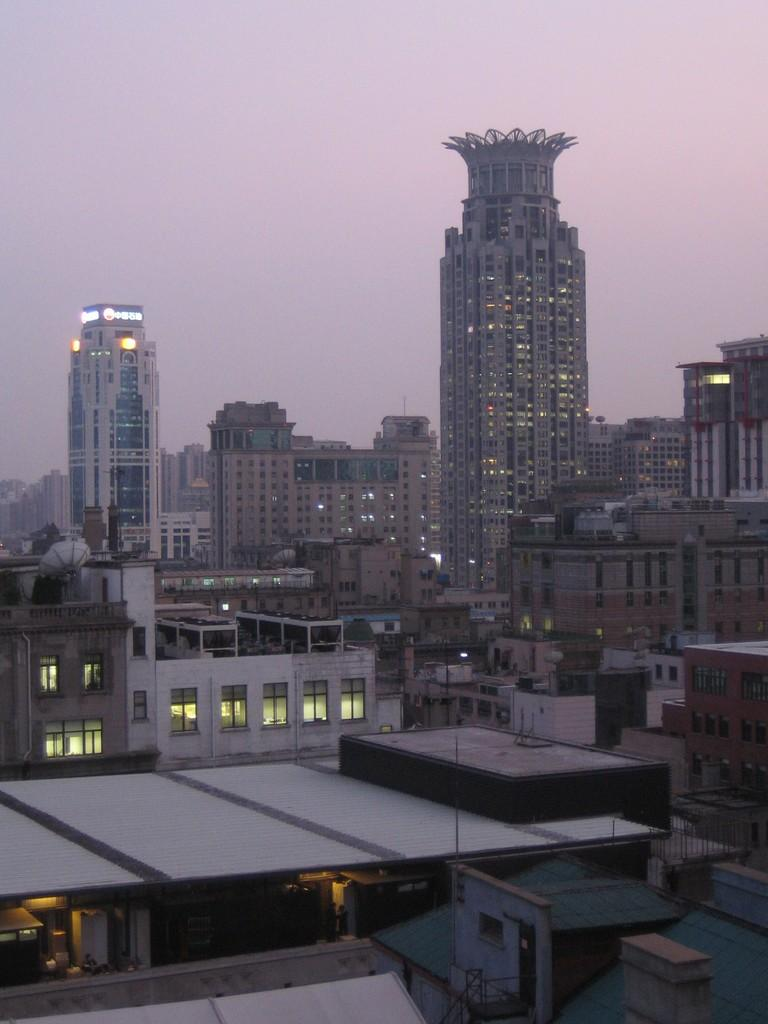What type of structures can be seen in the image? There are buildings in the image. What feature is present on the buildings? There are windows in the image. What can be seen illuminating the buildings? There are lights in the image. What type of signage is present in the image? There are boards in the image. What can be seen in the distance in the image? The sky is visible in the background of the image. How many women are sitting on the yam in the image? There is no yam or women present in the image. 